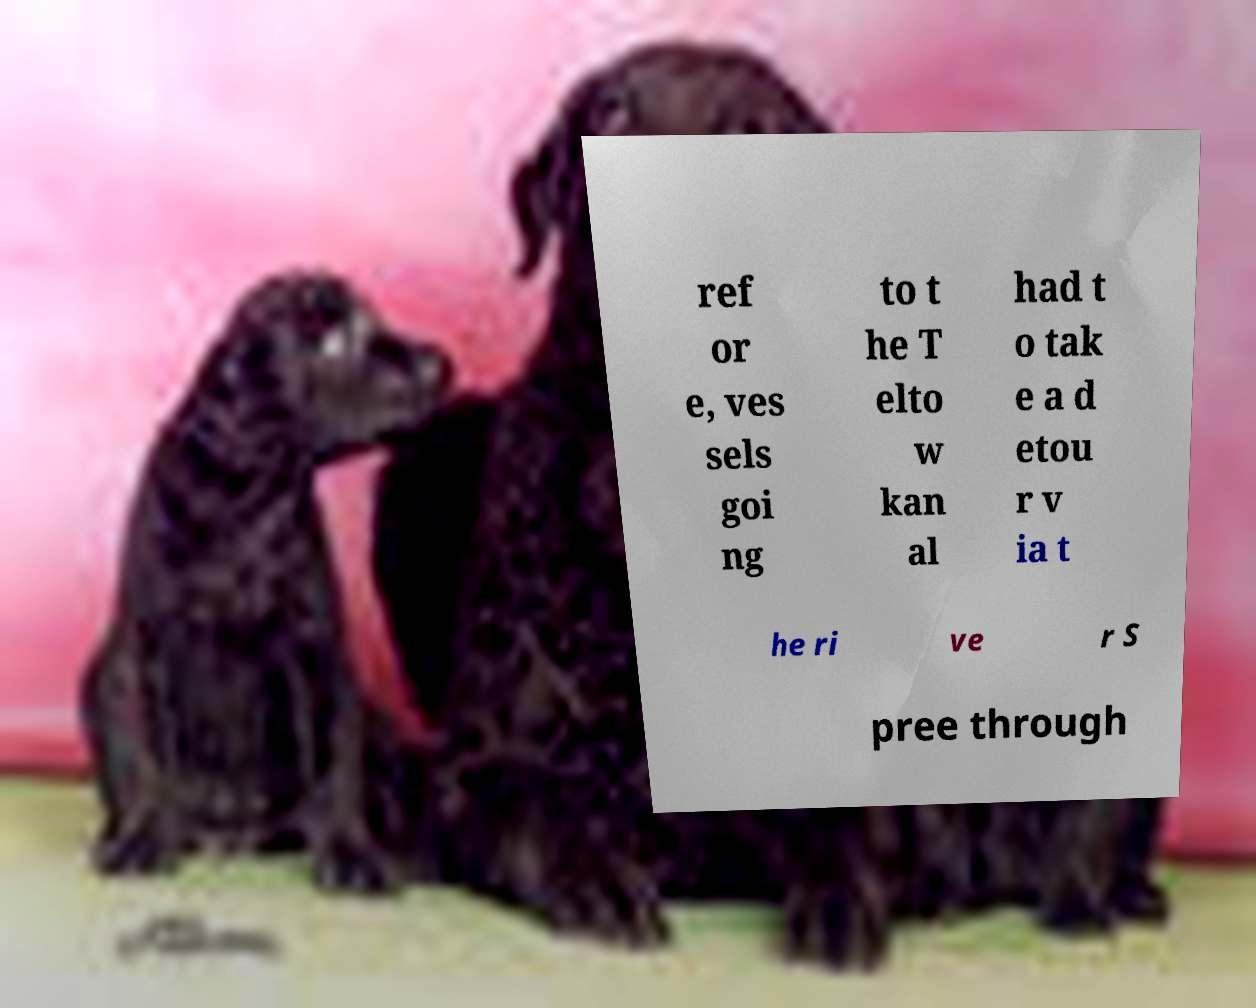For documentation purposes, I need the text within this image transcribed. Could you provide that? ref or e, ves sels goi ng to t he T elto w kan al had t o tak e a d etou r v ia t he ri ve r S pree through 